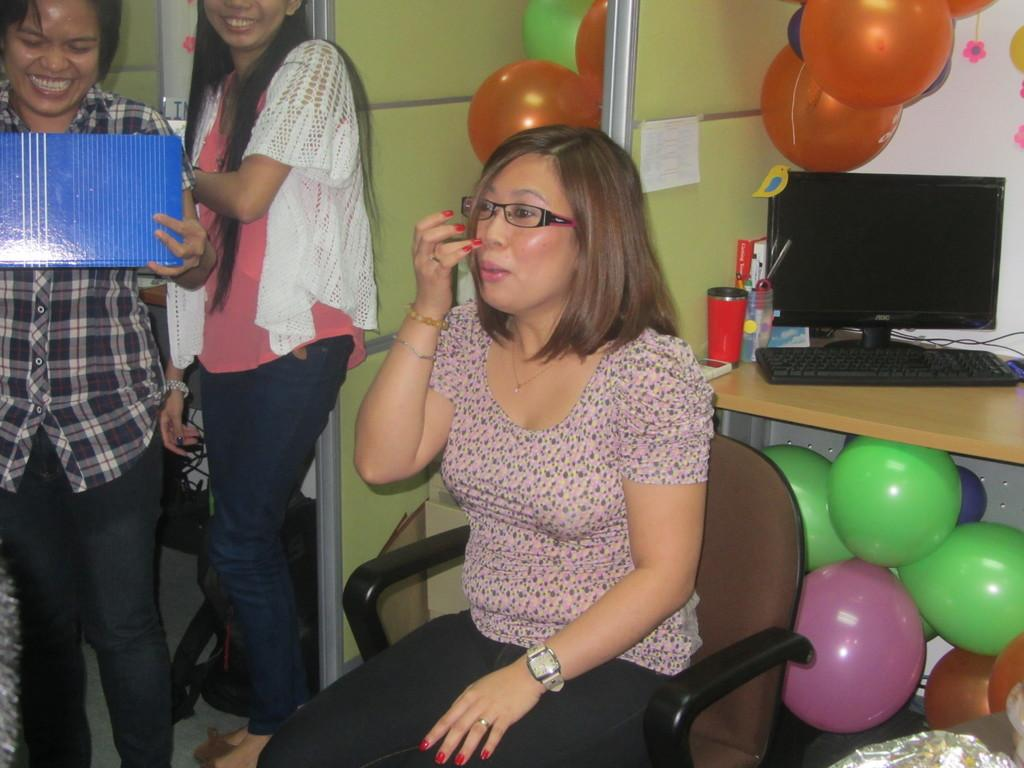What is the woman in the image doing? The woman is sitting on a chair in the image. Are there any other people in the image? Yes, there are other women standing in the image. What is on the floor in the image? There are balloons on the floor in the image. What is on the table in the image? There is a monitor on a table in the image. What type of office system is being used on the stage in the image? There is no office system or stage present in the image. 